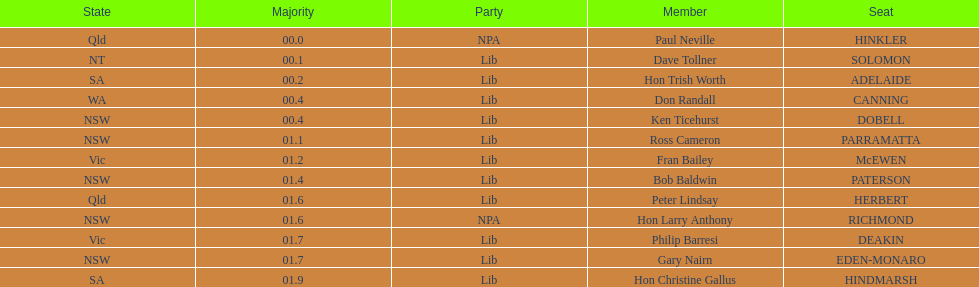How many members in total? 13. 